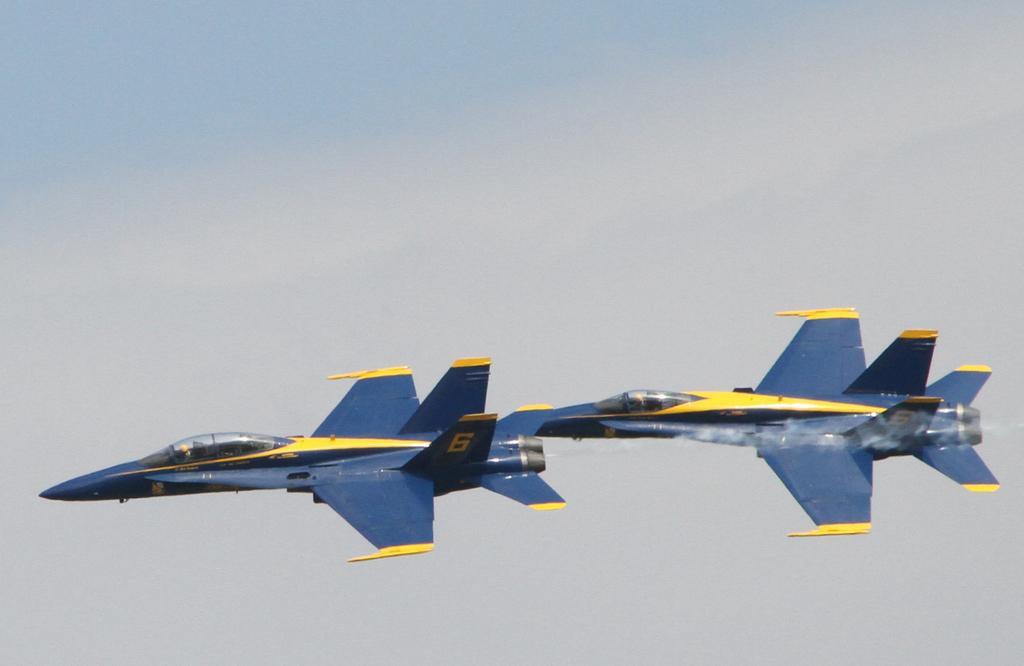<image>
Provide a brief description of the given image. A jet labelled "6" leads another jet through the air. 